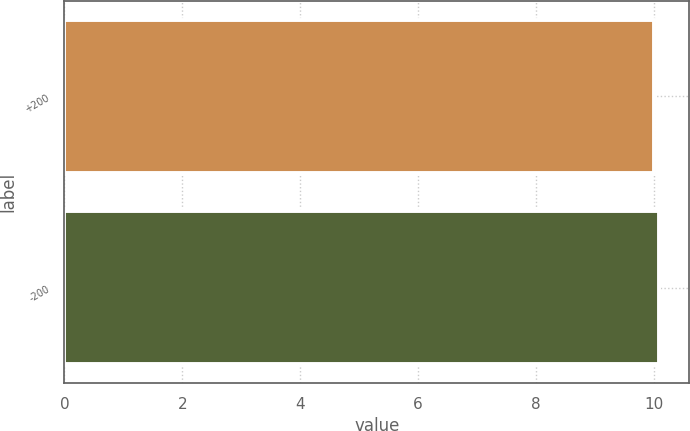<chart> <loc_0><loc_0><loc_500><loc_500><bar_chart><fcel>+200<fcel>-200<nl><fcel>10<fcel>10.1<nl></chart> 